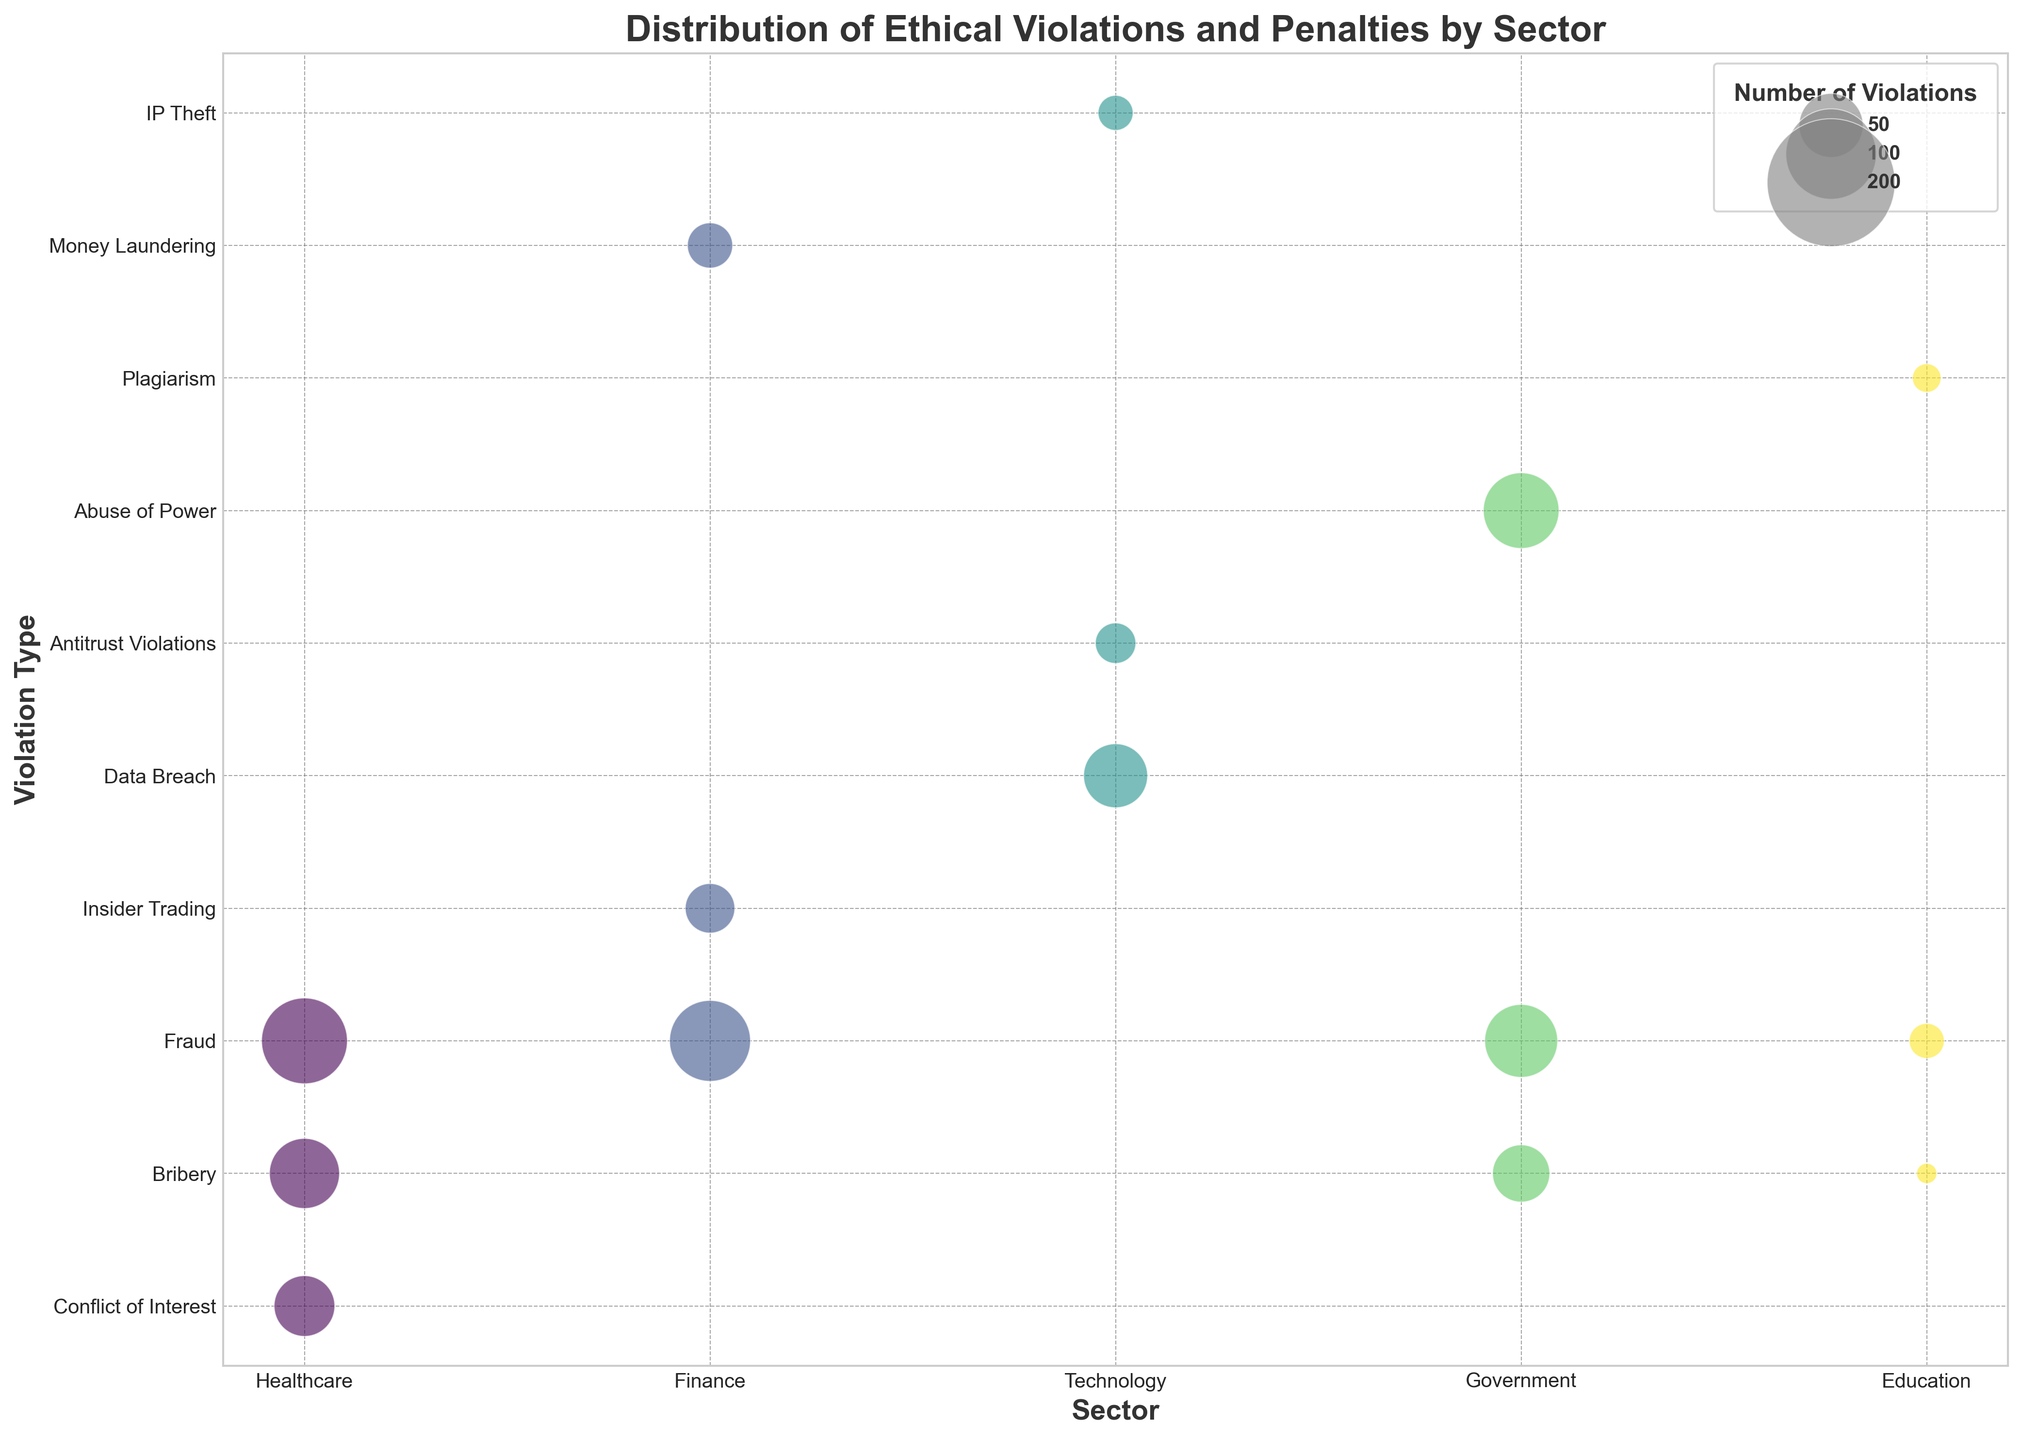What sector has the highest number of fraud violations? By looking at the sizes of the bubbles for "Fraud" in each sector, the largest bubble is in the Healthcare sector.
Answer: Healthcare Which violation type in the Finance sector has the highest total penalties? Comparing the bubbles in the Finance sector, "Fraud" has the highest total penalties as indicated by the size and context of the bubbles.
Answer: Fraud How does the average penalty for bribery in the Healthcare sector compare to that in the Government sector? The average penalty per violation for bribery in Healthcare is $120,000, while in the Government sector it's $150,000.
Answer: Government sector has a higher average penalty Which sector has the lowest number of violations for any given type, and what is the violation type? Looking for the smallest bubble, Education with Bribery has the lowest number with 5 violations.
Answer: Education, Bribery What is the total number of violations in the Technology sector? Summing up the number of violations: Data Breach (50) + Antitrust Violations (20) + IP Theft (15) = 85 violations.
Answer: 85 Compare the total penalties for fraud across all sectors. Which sector faces the highest total penalties for fraud? Adding the penalties for fraud in each sector: Healthcare ($13,500,000), Finance ($12,000,000), Government ($9,750,000), and Education ($2,250,000). The highest total is in the Healthcare sector.
Answer: Healthcare Is the average penalty per violation for antitrust violations in the Technology sector higher, lower, or equal to the average penalty per violation for insider trading in the Finance sector? The average penalty per violation for Antitrust Violations (Technology) is $200,000, and for Insider Trading (Finance) is also $200,000.
Answer: Equal How many more violations are there for fraud in the Finance sector compared to insider trading in the same sector? Fraud in Finance has 80 violations; Insider Trading has 30 violations. The difference is 80 - 30 = 50 violations.
Answer: 50 What is the ratio of the number of bribery violations in the Healthcare sector to the number of bribery violations in the Education sector? Bribery violations in Healthcare: 60; in Education: 5. The ratio is 60 / 5 = 12.
Answer: 12 Between Healthcare and Technology, which sector has a larger disparity in the number of violations between the two most frequent violation types? In Healthcare, the difference between Fraud (90) and Bribery (60) is 30. In Technology, the difference between Data Breach (50) and Antitrust Violations (20) is 30. Both sectors have the same disparity.
Answer: Both sectors have the same disparity of 30 